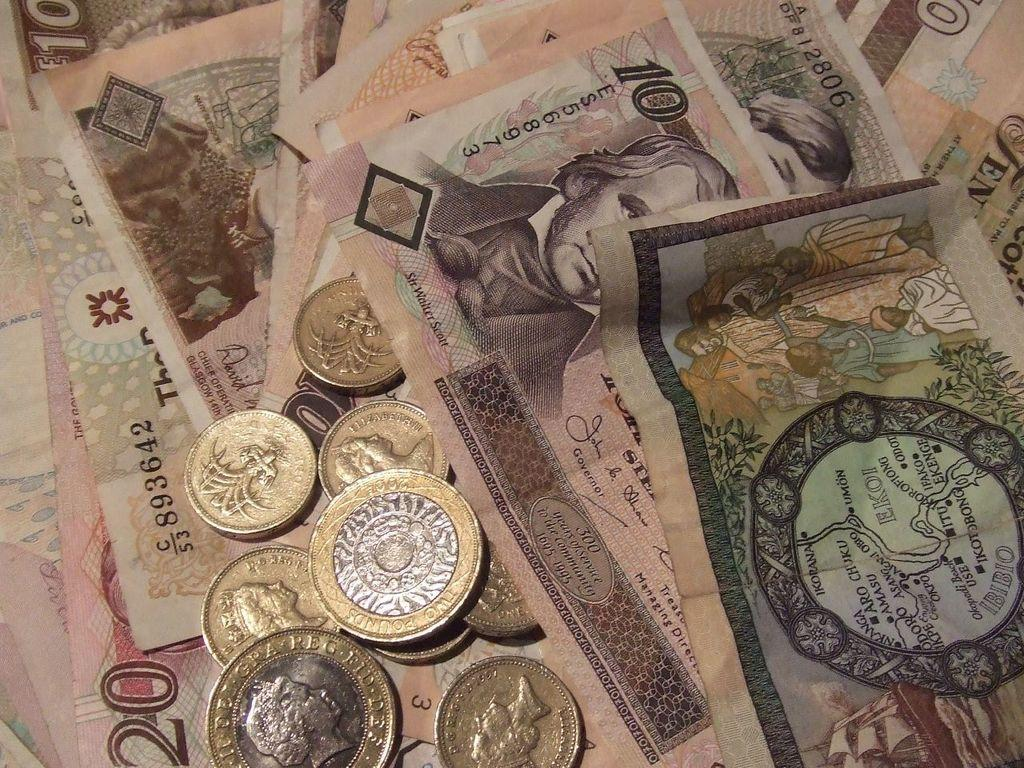<image>
Give a short and clear explanation of the subsequent image. A bill has the word Governor below the signature. 